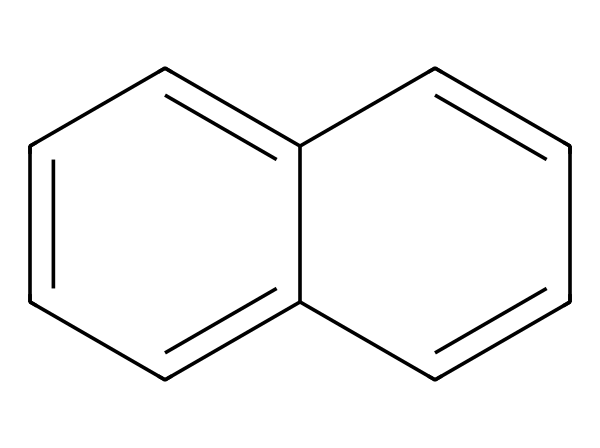How many carbon atoms are in naphthalene? The structure shows a total of ten carbon atoms, which are represented as the vertices of the overlapping aromatic rings.
Answer: ten What type of bonding is present in naphthalene? Naphthalene consists primarily of covalent bonds between the carbon atoms in the aromatic system. The structure indicates that each carbon is bonded to neighboring carbons through double bonds in a resonance structure, contributing to its stability.
Answer: covalent What is the molecular formula of naphthalene? From counting the carbon (C) and hydrogen (H) atoms in the molecular structure, we find there are 10 carbon atoms and 8 hydrogen atoms, leading to the formula C10H8.
Answer: C10H8 Does naphthalene have a distinct smell? Naphthalene, commonly found in mothballs, has a strong characteristic odor that is easily recognizable due to its volatile compounds.
Answer: yes Why is naphthalene used in mothballs? Naphthalene is effective in repelling moths due to its ability to sublime (transition from solid to gas) and release vapor that disrupts the lifecycle of moths, protecting clothing and fabrics.
Answer: to repel moths What is the significance of the aromatic rings in naphthalene? The presence of aromatic rings indicates naphthalene has delocalized electrons, which contributes to its stability, unique chemical reactivity, and characteristic aromatic properties, such as a pleasant smell.
Answer: stability 